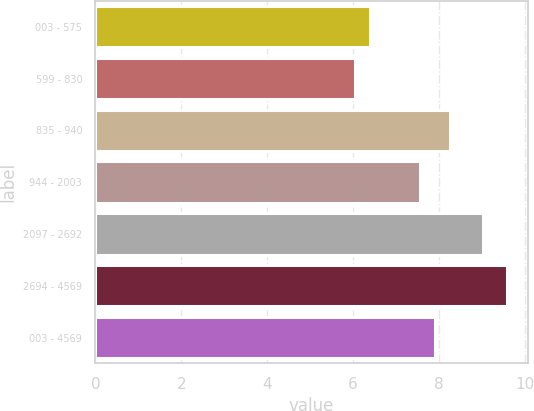Convert chart to OTSL. <chart><loc_0><loc_0><loc_500><loc_500><bar_chart><fcel>003 - 575<fcel>599 - 830<fcel>835 - 940<fcel>944 - 2003<fcel>2097 - 2692<fcel>2694 - 4569<fcel>003 - 4569<nl><fcel>6.39<fcel>6.04<fcel>8.25<fcel>7.55<fcel>9.01<fcel>9.58<fcel>7.9<nl></chart> 